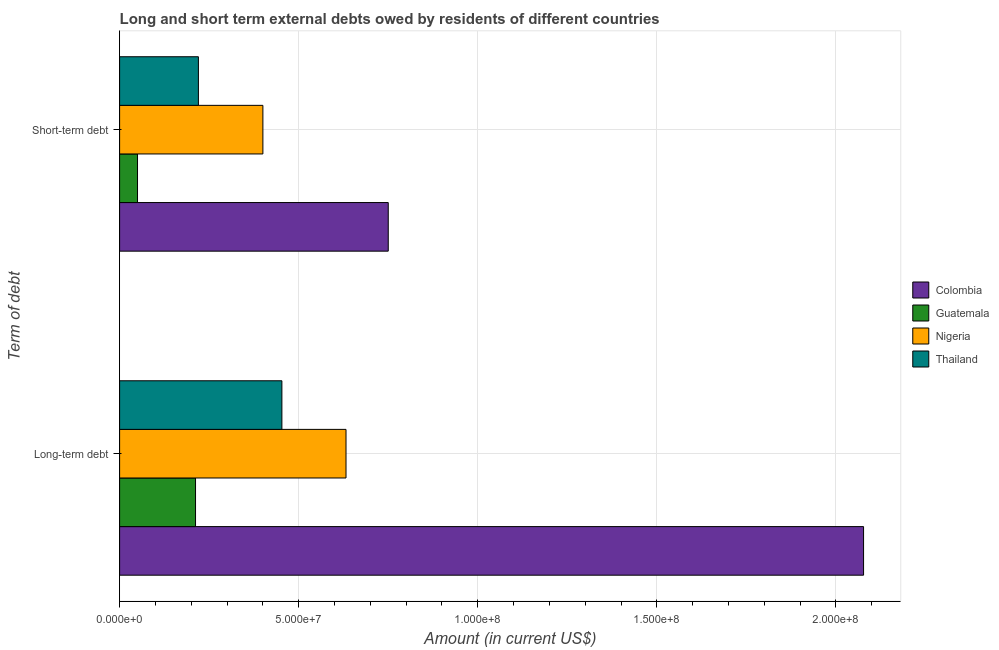How many groups of bars are there?
Offer a terse response. 2. How many bars are there on the 1st tick from the bottom?
Keep it short and to the point. 4. What is the label of the 2nd group of bars from the top?
Provide a short and direct response. Long-term debt. What is the long-term debts owed by residents in Colombia?
Make the answer very short. 2.08e+08. Across all countries, what is the maximum long-term debts owed by residents?
Your answer should be very brief. 2.08e+08. Across all countries, what is the minimum short-term debts owed by residents?
Your answer should be very brief. 5.00e+06. In which country was the short-term debts owed by residents maximum?
Provide a short and direct response. Colombia. In which country was the long-term debts owed by residents minimum?
Keep it short and to the point. Guatemala. What is the total long-term debts owed by residents in the graph?
Offer a very short reply. 3.37e+08. What is the difference between the long-term debts owed by residents in Thailand and that in Colombia?
Keep it short and to the point. -1.62e+08. What is the difference between the long-term debts owed by residents in Guatemala and the short-term debts owed by residents in Nigeria?
Provide a succinct answer. -1.88e+07. What is the average long-term debts owed by residents per country?
Your answer should be compact. 8.44e+07. What is the difference between the short-term debts owed by residents and long-term debts owed by residents in Guatemala?
Offer a very short reply. -1.62e+07. In how many countries, is the long-term debts owed by residents greater than 70000000 US$?
Make the answer very short. 1. What is the ratio of the short-term debts owed by residents in Thailand to that in Nigeria?
Give a very brief answer. 0.55. In how many countries, is the long-term debts owed by residents greater than the average long-term debts owed by residents taken over all countries?
Your response must be concise. 1. What does the 2nd bar from the top in Short-term debt represents?
Offer a very short reply. Nigeria. What does the 3rd bar from the bottom in Short-term debt represents?
Your response must be concise. Nigeria. How many bars are there?
Give a very brief answer. 8. Are all the bars in the graph horizontal?
Your answer should be very brief. Yes. How many countries are there in the graph?
Give a very brief answer. 4. What is the difference between two consecutive major ticks on the X-axis?
Ensure brevity in your answer.  5.00e+07. Does the graph contain grids?
Your response must be concise. Yes. How many legend labels are there?
Your answer should be compact. 4. How are the legend labels stacked?
Ensure brevity in your answer.  Vertical. What is the title of the graph?
Your answer should be compact. Long and short term external debts owed by residents of different countries. Does "Namibia" appear as one of the legend labels in the graph?
Your answer should be compact. No. What is the label or title of the X-axis?
Provide a succinct answer. Amount (in current US$). What is the label or title of the Y-axis?
Your answer should be compact. Term of debt. What is the Amount (in current US$) of Colombia in Long-term debt?
Your answer should be very brief. 2.08e+08. What is the Amount (in current US$) in Guatemala in Long-term debt?
Your response must be concise. 2.12e+07. What is the Amount (in current US$) in Nigeria in Long-term debt?
Offer a terse response. 6.32e+07. What is the Amount (in current US$) of Thailand in Long-term debt?
Your response must be concise. 4.53e+07. What is the Amount (in current US$) in Colombia in Short-term debt?
Offer a very short reply. 7.50e+07. What is the Amount (in current US$) in Guatemala in Short-term debt?
Your response must be concise. 5.00e+06. What is the Amount (in current US$) in Nigeria in Short-term debt?
Provide a short and direct response. 4.00e+07. What is the Amount (in current US$) in Thailand in Short-term debt?
Keep it short and to the point. 2.20e+07. Across all Term of debt, what is the maximum Amount (in current US$) in Colombia?
Provide a short and direct response. 2.08e+08. Across all Term of debt, what is the maximum Amount (in current US$) of Guatemala?
Provide a short and direct response. 2.12e+07. Across all Term of debt, what is the maximum Amount (in current US$) in Nigeria?
Provide a short and direct response. 6.32e+07. Across all Term of debt, what is the maximum Amount (in current US$) in Thailand?
Make the answer very short. 4.53e+07. Across all Term of debt, what is the minimum Amount (in current US$) in Colombia?
Your response must be concise. 7.50e+07. Across all Term of debt, what is the minimum Amount (in current US$) of Guatemala?
Offer a terse response. 5.00e+06. Across all Term of debt, what is the minimum Amount (in current US$) in Nigeria?
Your answer should be compact. 4.00e+07. Across all Term of debt, what is the minimum Amount (in current US$) of Thailand?
Offer a terse response. 2.20e+07. What is the total Amount (in current US$) in Colombia in the graph?
Your response must be concise. 2.83e+08. What is the total Amount (in current US$) of Guatemala in the graph?
Ensure brevity in your answer.  2.62e+07. What is the total Amount (in current US$) of Nigeria in the graph?
Provide a succinct answer. 1.03e+08. What is the total Amount (in current US$) of Thailand in the graph?
Make the answer very short. 6.73e+07. What is the difference between the Amount (in current US$) in Colombia in Long-term debt and that in Short-term debt?
Offer a terse response. 1.33e+08. What is the difference between the Amount (in current US$) of Guatemala in Long-term debt and that in Short-term debt?
Ensure brevity in your answer.  1.62e+07. What is the difference between the Amount (in current US$) of Nigeria in Long-term debt and that in Short-term debt?
Keep it short and to the point. 2.32e+07. What is the difference between the Amount (in current US$) in Thailand in Long-term debt and that in Short-term debt?
Give a very brief answer. 2.33e+07. What is the difference between the Amount (in current US$) in Colombia in Long-term debt and the Amount (in current US$) in Guatemala in Short-term debt?
Give a very brief answer. 2.03e+08. What is the difference between the Amount (in current US$) in Colombia in Long-term debt and the Amount (in current US$) in Nigeria in Short-term debt?
Give a very brief answer. 1.68e+08. What is the difference between the Amount (in current US$) in Colombia in Long-term debt and the Amount (in current US$) in Thailand in Short-term debt?
Your answer should be very brief. 1.86e+08. What is the difference between the Amount (in current US$) of Guatemala in Long-term debt and the Amount (in current US$) of Nigeria in Short-term debt?
Keep it short and to the point. -1.88e+07. What is the difference between the Amount (in current US$) of Guatemala in Long-term debt and the Amount (in current US$) of Thailand in Short-term debt?
Make the answer very short. -8.04e+05. What is the difference between the Amount (in current US$) of Nigeria in Long-term debt and the Amount (in current US$) of Thailand in Short-term debt?
Your answer should be compact. 4.12e+07. What is the average Amount (in current US$) in Colombia per Term of debt?
Keep it short and to the point. 1.41e+08. What is the average Amount (in current US$) of Guatemala per Term of debt?
Your answer should be compact. 1.31e+07. What is the average Amount (in current US$) in Nigeria per Term of debt?
Your answer should be very brief. 5.16e+07. What is the average Amount (in current US$) of Thailand per Term of debt?
Your answer should be very brief. 3.37e+07. What is the difference between the Amount (in current US$) in Colombia and Amount (in current US$) in Guatemala in Long-term debt?
Provide a succinct answer. 1.87e+08. What is the difference between the Amount (in current US$) in Colombia and Amount (in current US$) in Nigeria in Long-term debt?
Ensure brevity in your answer.  1.44e+08. What is the difference between the Amount (in current US$) of Colombia and Amount (in current US$) of Thailand in Long-term debt?
Provide a succinct answer. 1.62e+08. What is the difference between the Amount (in current US$) of Guatemala and Amount (in current US$) of Nigeria in Long-term debt?
Your answer should be compact. -4.20e+07. What is the difference between the Amount (in current US$) of Guatemala and Amount (in current US$) of Thailand in Long-term debt?
Give a very brief answer. -2.41e+07. What is the difference between the Amount (in current US$) of Nigeria and Amount (in current US$) of Thailand in Long-term debt?
Offer a very short reply. 1.79e+07. What is the difference between the Amount (in current US$) in Colombia and Amount (in current US$) in Guatemala in Short-term debt?
Your answer should be very brief. 7.00e+07. What is the difference between the Amount (in current US$) of Colombia and Amount (in current US$) of Nigeria in Short-term debt?
Offer a terse response. 3.50e+07. What is the difference between the Amount (in current US$) of Colombia and Amount (in current US$) of Thailand in Short-term debt?
Give a very brief answer. 5.30e+07. What is the difference between the Amount (in current US$) of Guatemala and Amount (in current US$) of Nigeria in Short-term debt?
Your answer should be very brief. -3.50e+07. What is the difference between the Amount (in current US$) of Guatemala and Amount (in current US$) of Thailand in Short-term debt?
Your answer should be very brief. -1.70e+07. What is the difference between the Amount (in current US$) of Nigeria and Amount (in current US$) of Thailand in Short-term debt?
Your answer should be compact. 1.80e+07. What is the ratio of the Amount (in current US$) of Colombia in Long-term debt to that in Short-term debt?
Keep it short and to the point. 2.77. What is the ratio of the Amount (in current US$) in Guatemala in Long-term debt to that in Short-term debt?
Offer a very short reply. 4.24. What is the ratio of the Amount (in current US$) in Nigeria in Long-term debt to that in Short-term debt?
Your answer should be compact. 1.58. What is the ratio of the Amount (in current US$) in Thailand in Long-term debt to that in Short-term debt?
Ensure brevity in your answer.  2.06. What is the difference between the highest and the second highest Amount (in current US$) of Colombia?
Give a very brief answer. 1.33e+08. What is the difference between the highest and the second highest Amount (in current US$) in Guatemala?
Your answer should be very brief. 1.62e+07. What is the difference between the highest and the second highest Amount (in current US$) of Nigeria?
Ensure brevity in your answer.  2.32e+07. What is the difference between the highest and the second highest Amount (in current US$) of Thailand?
Offer a terse response. 2.33e+07. What is the difference between the highest and the lowest Amount (in current US$) in Colombia?
Your answer should be compact. 1.33e+08. What is the difference between the highest and the lowest Amount (in current US$) in Guatemala?
Offer a very short reply. 1.62e+07. What is the difference between the highest and the lowest Amount (in current US$) of Nigeria?
Provide a succinct answer. 2.32e+07. What is the difference between the highest and the lowest Amount (in current US$) of Thailand?
Your response must be concise. 2.33e+07. 